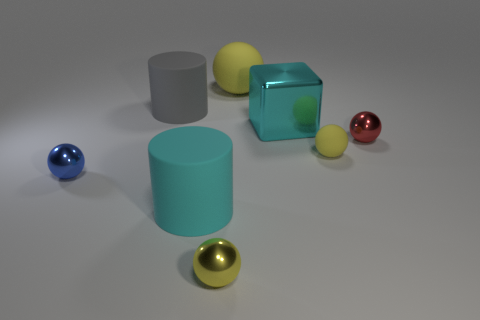There is a matte object that is behind the rubber cylinder that is behind the cyan metal object; what is its size?
Your response must be concise. Large. There is a cyan cylinder that is the same size as the gray matte cylinder; what is its material?
Give a very brief answer. Rubber. How many other objects are there of the same size as the gray rubber cylinder?
Provide a succinct answer. 3. How many cylinders are cyan things or big yellow things?
Provide a short and direct response. 1. What material is the cylinder that is in front of the tiny sphere that is on the left side of the matte cylinder on the right side of the gray rubber thing?
Give a very brief answer. Rubber. What material is the big ball that is the same color as the small matte ball?
Make the answer very short. Rubber. How many yellow balls have the same material as the red ball?
Your response must be concise. 1. Does the yellow rubber sphere on the left side of the cyan cube have the same size as the tiny yellow shiny ball?
Your answer should be compact. No. There is a ball that is made of the same material as the big yellow object; what color is it?
Keep it short and to the point. Yellow. There is a tiny yellow metal ball; what number of big objects are to the left of it?
Your answer should be compact. 2. 